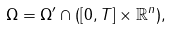Convert formula to latex. <formula><loc_0><loc_0><loc_500><loc_500>\Omega = \Omega ^ { \prime } \cap ( [ 0 , T ] \times \mathbb { R } ^ { n } ) ,</formula> 